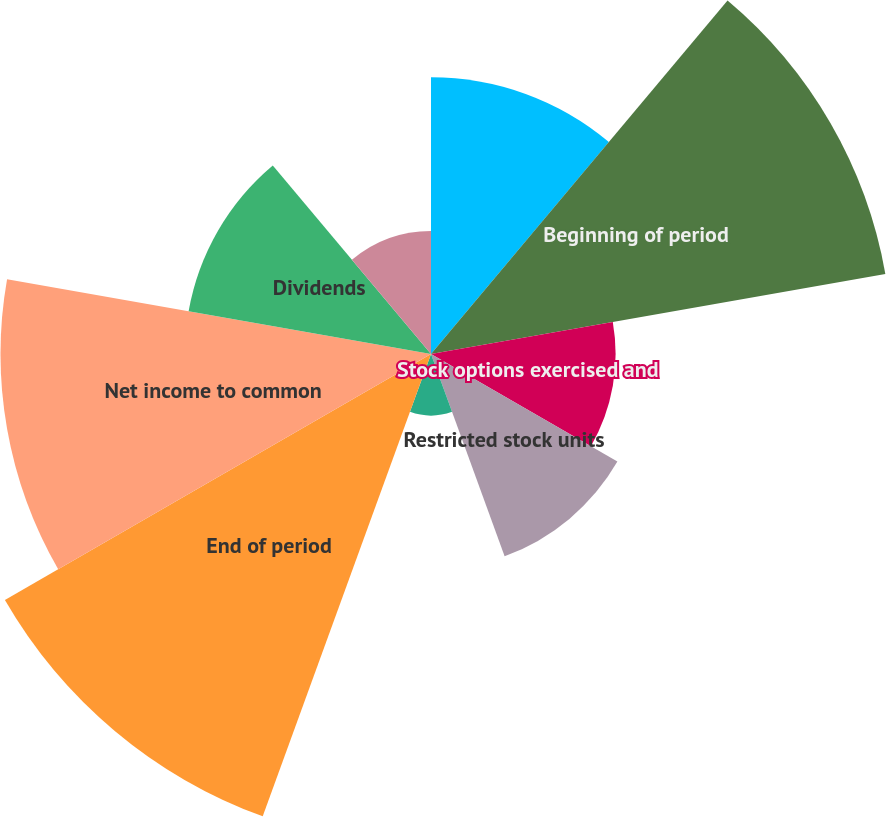<chart> <loc_0><loc_0><loc_500><loc_500><pie_chart><fcel>Beginning and end of period<fcel>Beginning of period<fcel>Stock options exercised and<fcel>Restricted stock units<fcel>Stock issued<fcel>End of period<fcel>Net income to common<fcel>Dividends<fcel>Unrealized gains (losses) on<nl><fcel>11.11%<fcel>18.52%<fcel>7.41%<fcel>8.64%<fcel>2.47%<fcel>19.75%<fcel>17.28%<fcel>9.88%<fcel>4.94%<nl></chart> 